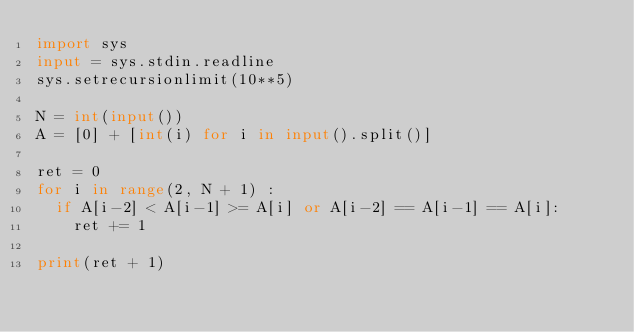Convert code to text. <code><loc_0><loc_0><loc_500><loc_500><_Python_>import sys
input = sys.stdin.readline
sys.setrecursionlimit(10**5)

N = int(input())
A = [0] + [int(i) for i in input().split()]

ret = 0
for i in range(2, N + 1) :
  if A[i-2] < A[i-1] >= A[i] or A[i-2] == A[i-1] == A[i]:
    ret += 1

print(ret + 1)</code> 